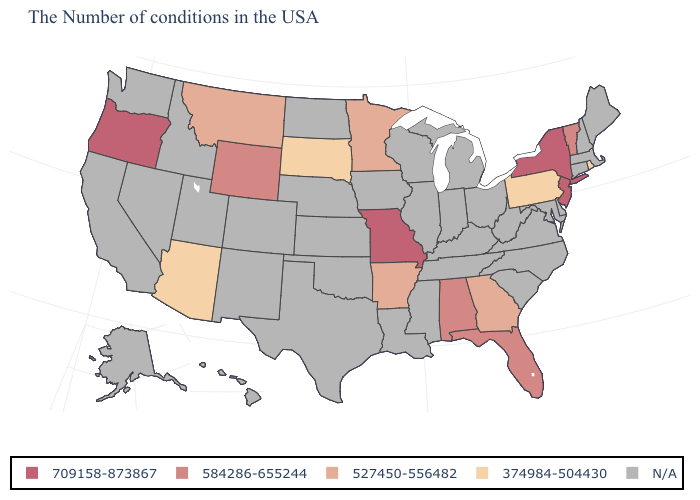What is the value of Montana?
Be succinct. 527450-556482. What is the value of Connecticut?
Short answer required. N/A. Name the states that have a value in the range 374984-504430?
Keep it brief. Rhode Island, Pennsylvania, South Dakota, Arizona. Name the states that have a value in the range 709158-873867?
Keep it brief. New York, New Jersey, Missouri, Oregon. Name the states that have a value in the range 527450-556482?
Concise answer only. Georgia, Arkansas, Minnesota, Montana. What is the value of Kansas?
Write a very short answer. N/A. What is the lowest value in the Northeast?
Keep it brief. 374984-504430. Name the states that have a value in the range 709158-873867?
Answer briefly. New York, New Jersey, Missouri, Oregon. Name the states that have a value in the range 374984-504430?
Quick response, please. Rhode Island, Pennsylvania, South Dakota, Arizona. Among the states that border Illinois , which have the lowest value?
Short answer required. Missouri. Name the states that have a value in the range N/A?
Quick response, please. Maine, Massachusetts, New Hampshire, Connecticut, Delaware, Maryland, Virginia, North Carolina, South Carolina, West Virginia, Ohio, Michigan, Kentucky, Indiana, Tennessee, Wisconsin, Illinois, Mississippi, Louisiana, Iowa, Kansas, Nebraska, Oklahoma, Texas, North Dakota, Colorado, New Mexico, Utah, Idaho, Nevada, California, Washington, Alaska, Hawaii. Does New Jersey have the highest value in the USA?
Quick response, please. Yes. 